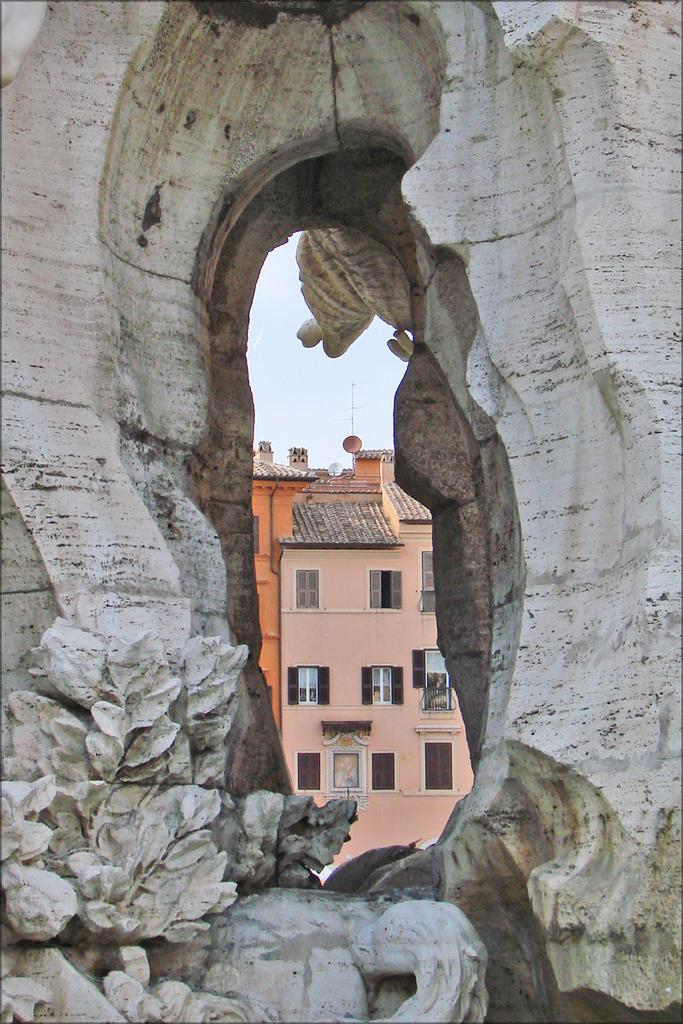What is the main object in the image? There is a stone in the image. What feature is present on the stone? There is a hole in the stone. What can be seen through the hole in the stone? A building and the sky are visible through the hole in the stone. How many geese are visible through the hole in the stone? There are no geese visible through the hole in the stone; only a building and the sky can be seen. What fact about the stone can be determined from the image? The fact that there is a hole in the stone can be determined from the image. 